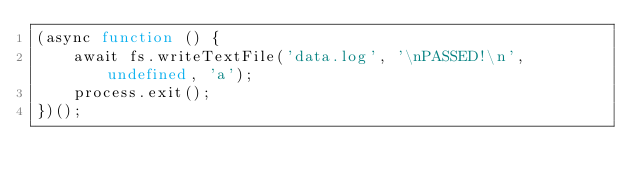Convert code to text. <code><loc_0><loc_0><loc_500><loc_500><_TypeScript_>(async function () {
    await fs.writeTextFile('data.log', '\nPASSED!\n', undefined, 'a');
    process.exit();
})();</code> 